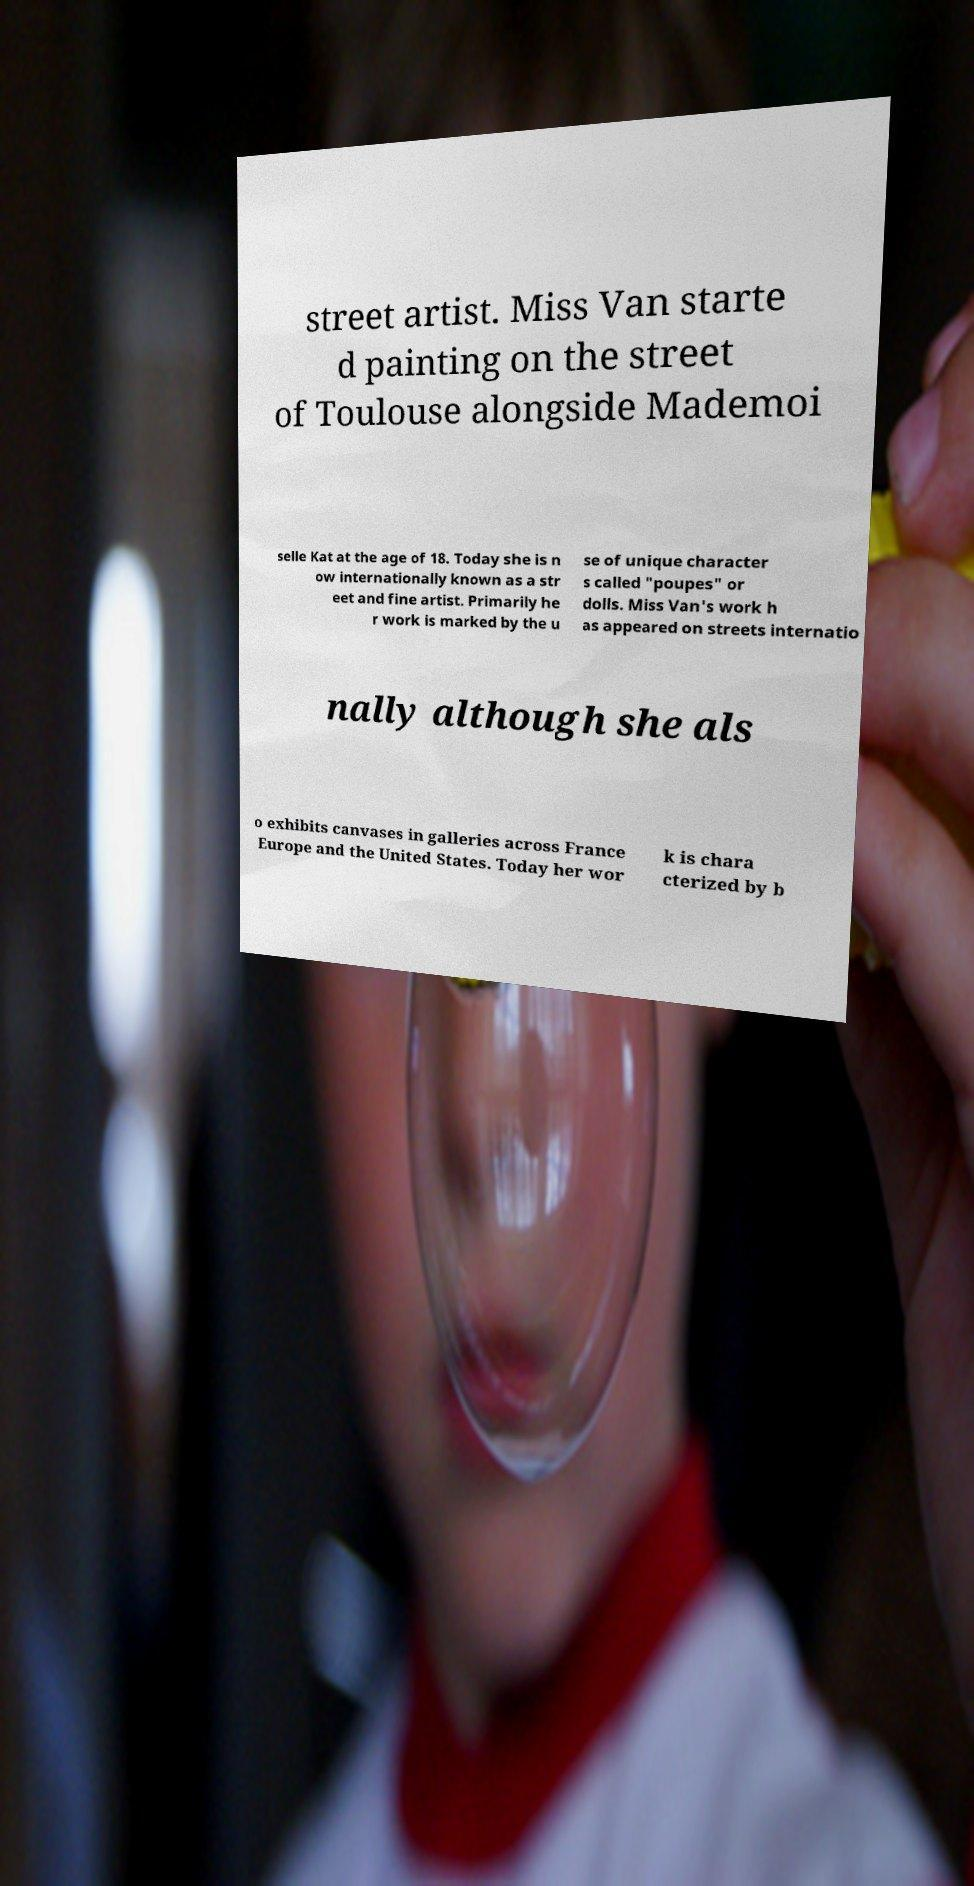Could you extract and type out the text from this image? street artist. Miss Van starte d painting on the street of Toulouse alongside Mademoi selle Kat at the age of 18. Today she is n ow internationally known as a str eet and fine artist. Primarily he r work is marked by the u se of unique character s called "poupes" or dolls. Miss Van's work h as appeared on streets internatio nally although she als o exhibits canvases in galleries across France Europe and the United States. Today her wor k is chara cterized by b 